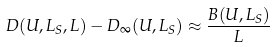<formula> <loc_0><loc_0><loc_500><loc_500>D ( U , L _ { S } , L ) - D _ { \infty } ( U , L _ { S } ) \approx \frac { B ( U , L _ { S } ) } { L }</formula> 